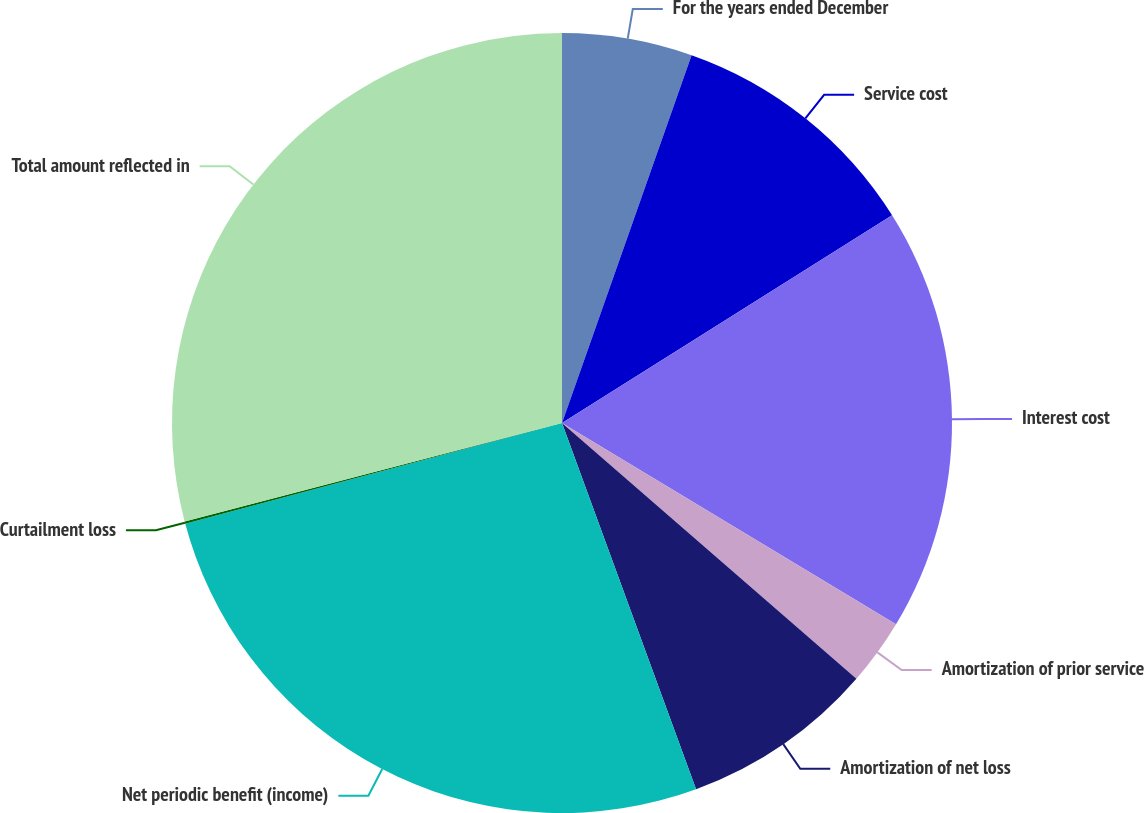<chart> <loc_0><loc_0><loc_500><loc_500><pie_chart><fcel>For the years ended December<fcel>Service cost<fcel>Interest cost<fcel>Amortization of prior service<fcel>Amortization of net loss<fcel>Net periodic benefit (income)<fcel>Curtailment loss<fcel>Total amount reflected in<nl><fcel>5.39%<fcel>10.67%<fcel>17.57%<fcel>2.75%<fcel>8.03%<fcel>26.42%<fcel>0.1%<fcel>29.06%<nl></chart> 